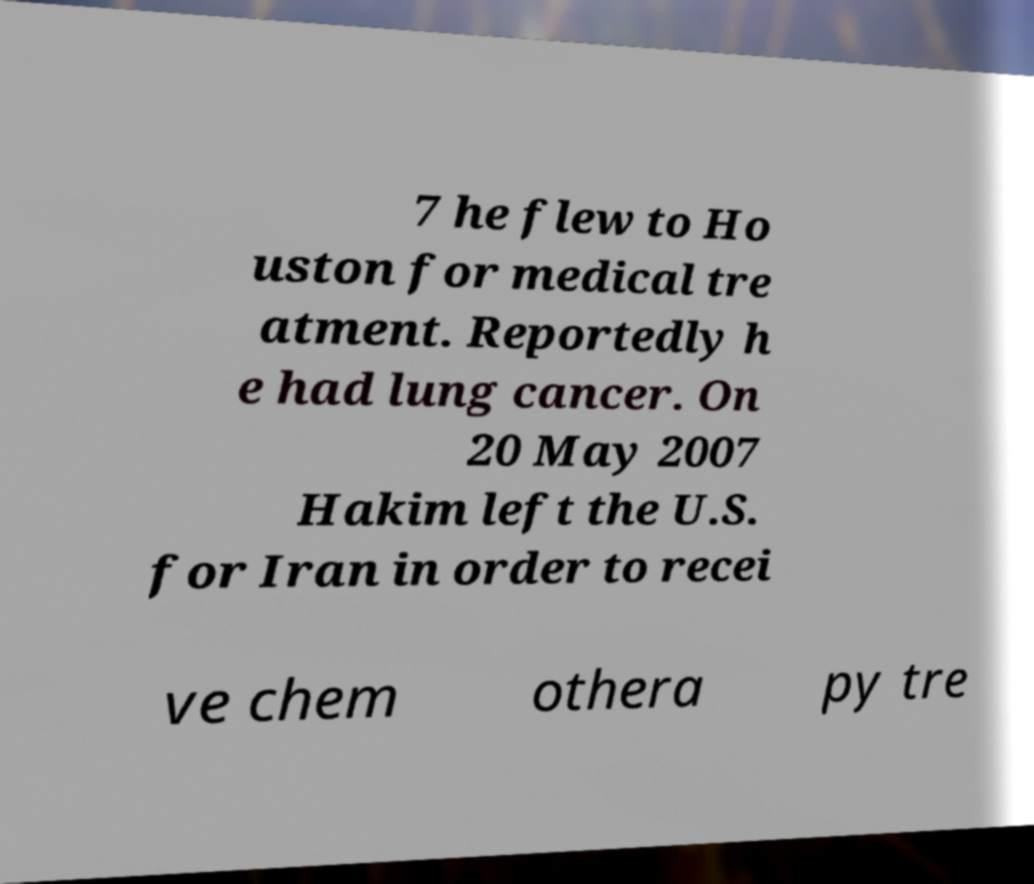What messages or text are displayed in this image? I need them in a readable, typed format. 7 he flew to Ho uston for medical tre atment. Reportedly h e had lung cancer. On 20 May 2007 Hakim left the U.S. for Iran in order to recei ve chem othera py tre 